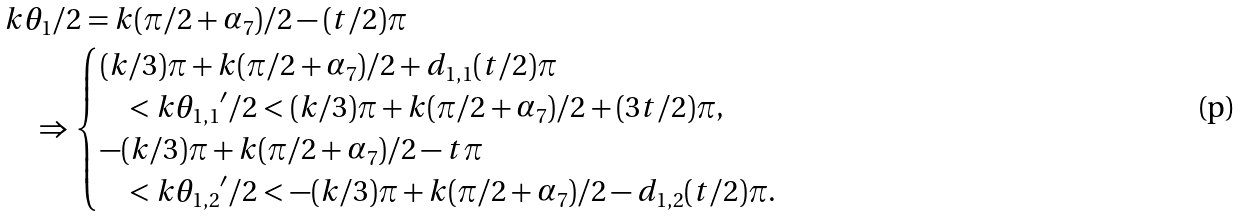<formula> <loc_0><loc_0><loc_500><loc_500>& k \theta _ { 1 } / 2 = k ( \pi / 2 + \alpha _ { 7 } ) / 2 - ( t / 2 ) \pi \\ & \quad \Rightarrow \begin{cases} ( k / 3 ) \pi + k ( \pi / 2 + \alpha _ { 7 } ) / 2 + d _ { 1 , 1 } ( t / 2 ) \pi \\ \quad < k { \theta _ { 1 , 1 } } ^ { \prime } / 2 < ( k / 3 ) \pi + k ( \pi / 2 + \alpha _ { 7 } ) / 2 + ( 3 t / 2 ) \pi , \\ - ( k / 3 ) \pi + k ( \pi / 2 + \alpha _ { 7 } ) / 2 - t \pi \\ \quad < k { \theta _ { 1 , 2 } } ^ { \prime } / 2 < - ( k / 3 ) \pi + k ( \pi / 2 + \alpha _ { 7 } ) / 2 - d _ { 1 , 2 } ( t / 2 ) \pi . \end{cases}</formula> 